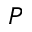<formula> <loc_0><loc_0><loc_500><loc_500>P</formula> 